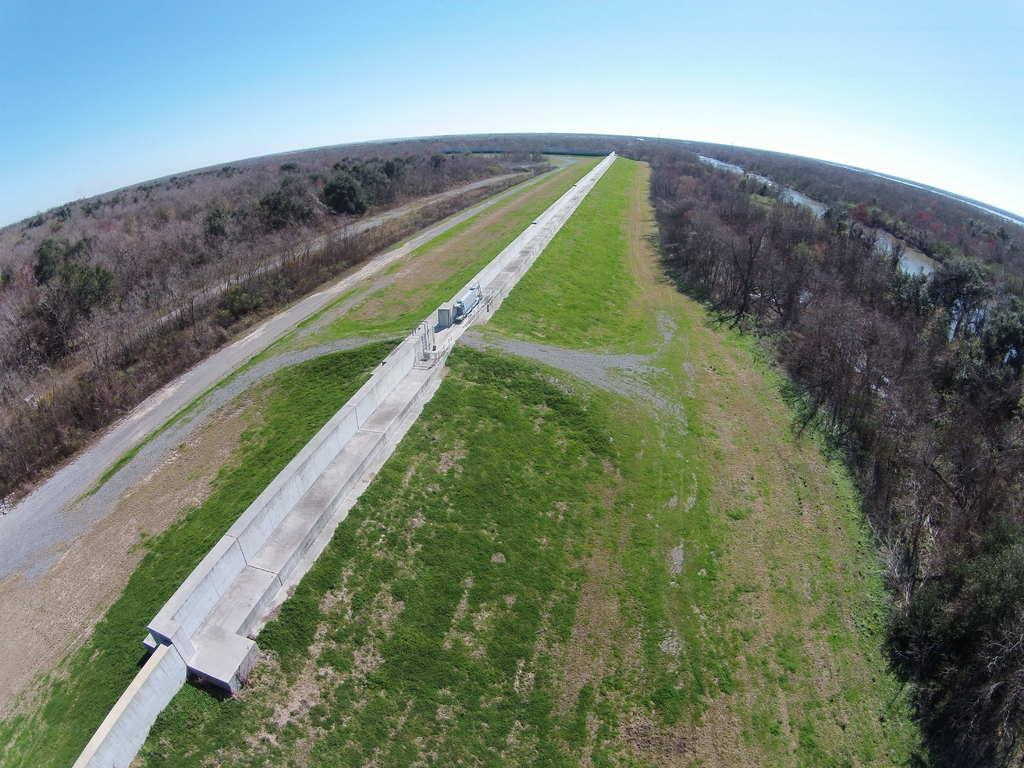What type of vehicles can be seen on the road in the image? There are motor vehicles on the road in the image. What can be seen on the ground in the image? The ground is visible in the image. What type of vegetation is present in the image? There are trees in the image. What is visible in the sky in the image? The sky is visible in the image, and clouds are present. Can you see any chess pieces on the road in the image? There are no chess pieces present in the image. Are there any bears visible in the image? There are no bears present in the image. 